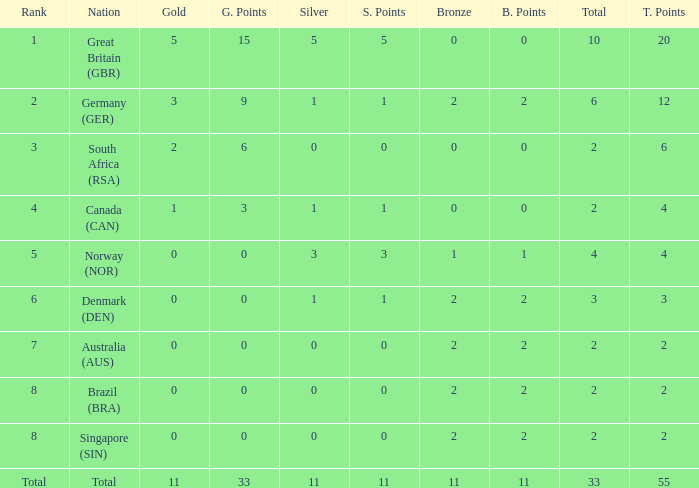What is bronze when the rank is 3 and the total is more than 2? None. 